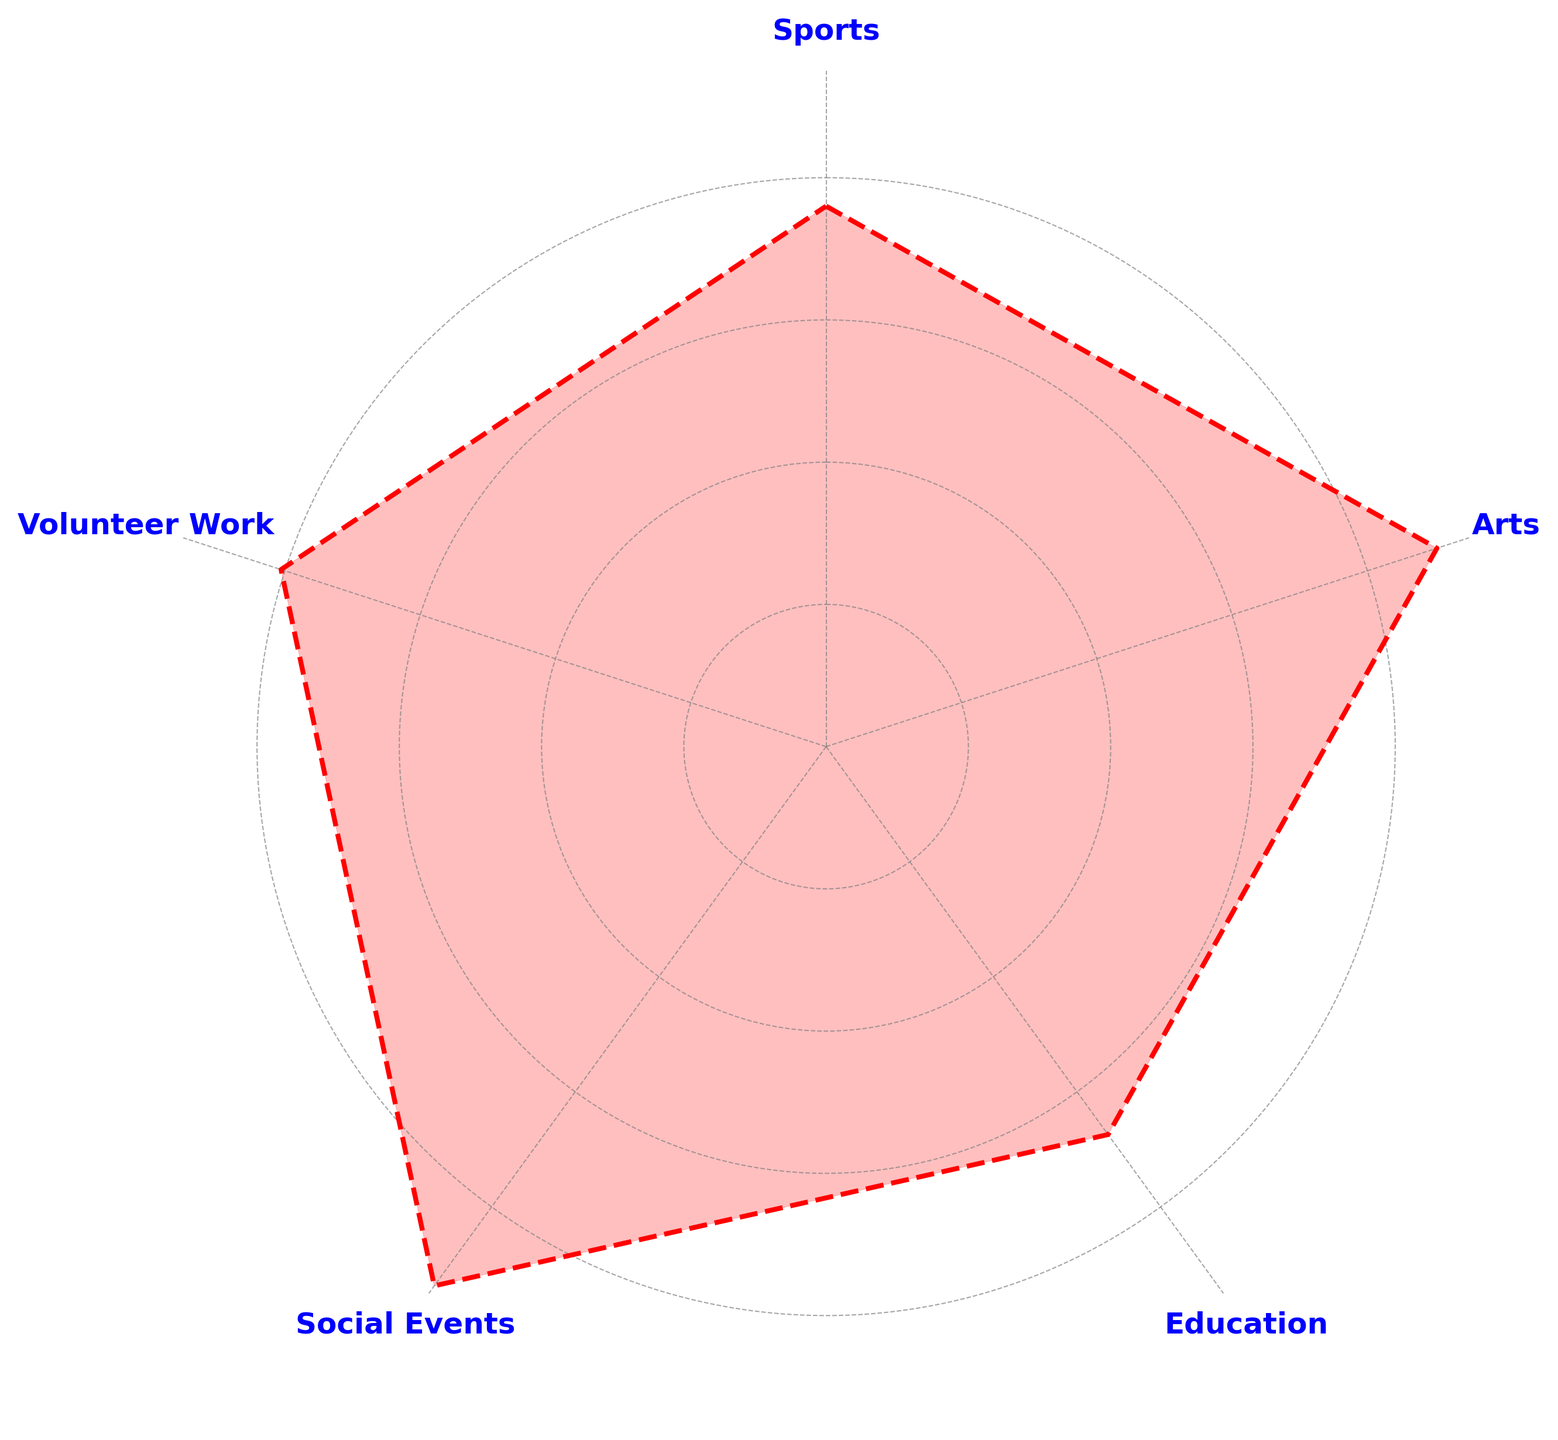What activity has the highest average popularity among wheelchair users? By observing the height of the areas, we can identify that Sports has the highest average popularity as its corresponding area is the most extended outwards.
Answer: Sports What is the average popularity of Education activities? To find the average popularity, we add the values provided for Education and divide by the number of samples. The data shows: (21 + 23 + 20 + 24 + 23 + 25 + 22) / 7 = 22.57
Answer: 22.57 Between Arts and Volunteer Work, which activity has a greater average popularity? Comparing the two areas, we see that Volunteer Work extends further outwards than Arts, indicating a higher average popularity.
Answer: Volunteer Work How does the average popularity of Social Events compare with Education? Social Events has a smaller area compared to Education, indicating a lower average popularity. Education has a significantly larger area.
Answer: Social Events is less popular than Education What is the least popular activity among wheelchair users? By observing the chart, we notice that Social Events has the smallest area, indicating it has the lowest average popularity.
Answer: Social Events 